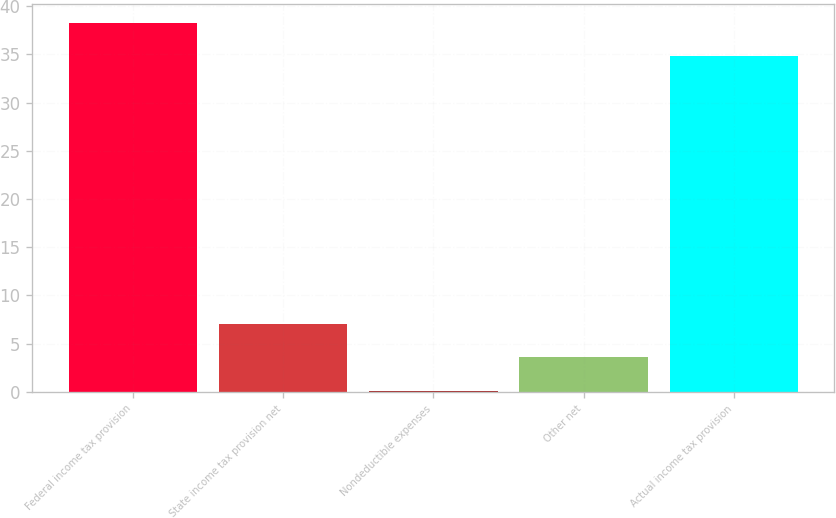<chart> <loc_0><loc_0><loc_500><loc_500><bar_chart><fcel>Federal income tax provision<fcel>State income tax provision net<fcel>Nondeductible expenses<fcel>Other net<fcel>Actual income tax provision<nl><fcel>38.29<fcel>7.08<fcel>0.1<fcel>3.59<fcel>34.8<nl></chart> 